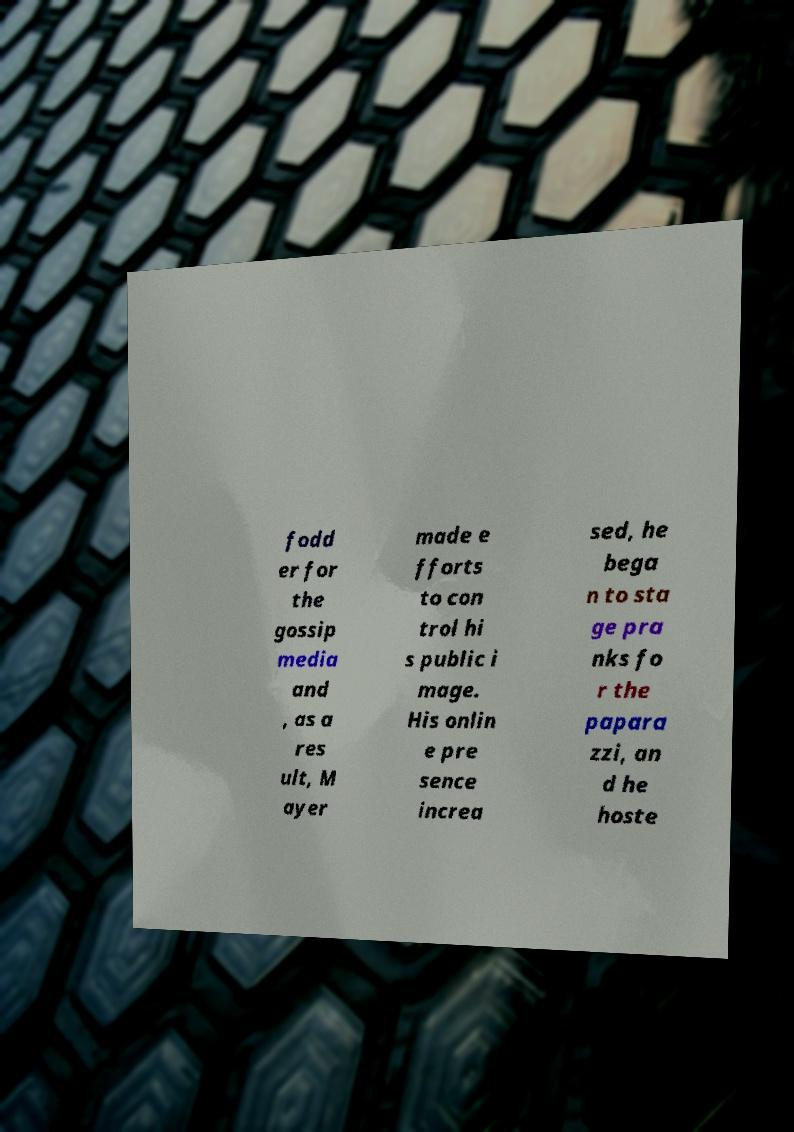There's text embedded in this image that I need extracted. Can you transcribe it verbatim? fodd er for the gossip media and , as a res ult, M ayer made e fforts to con trol hi s public i mage. His onlin e pre sence increa sed, he bega n to sta ge pra nks fo r the papara zzi, an d he hoste 